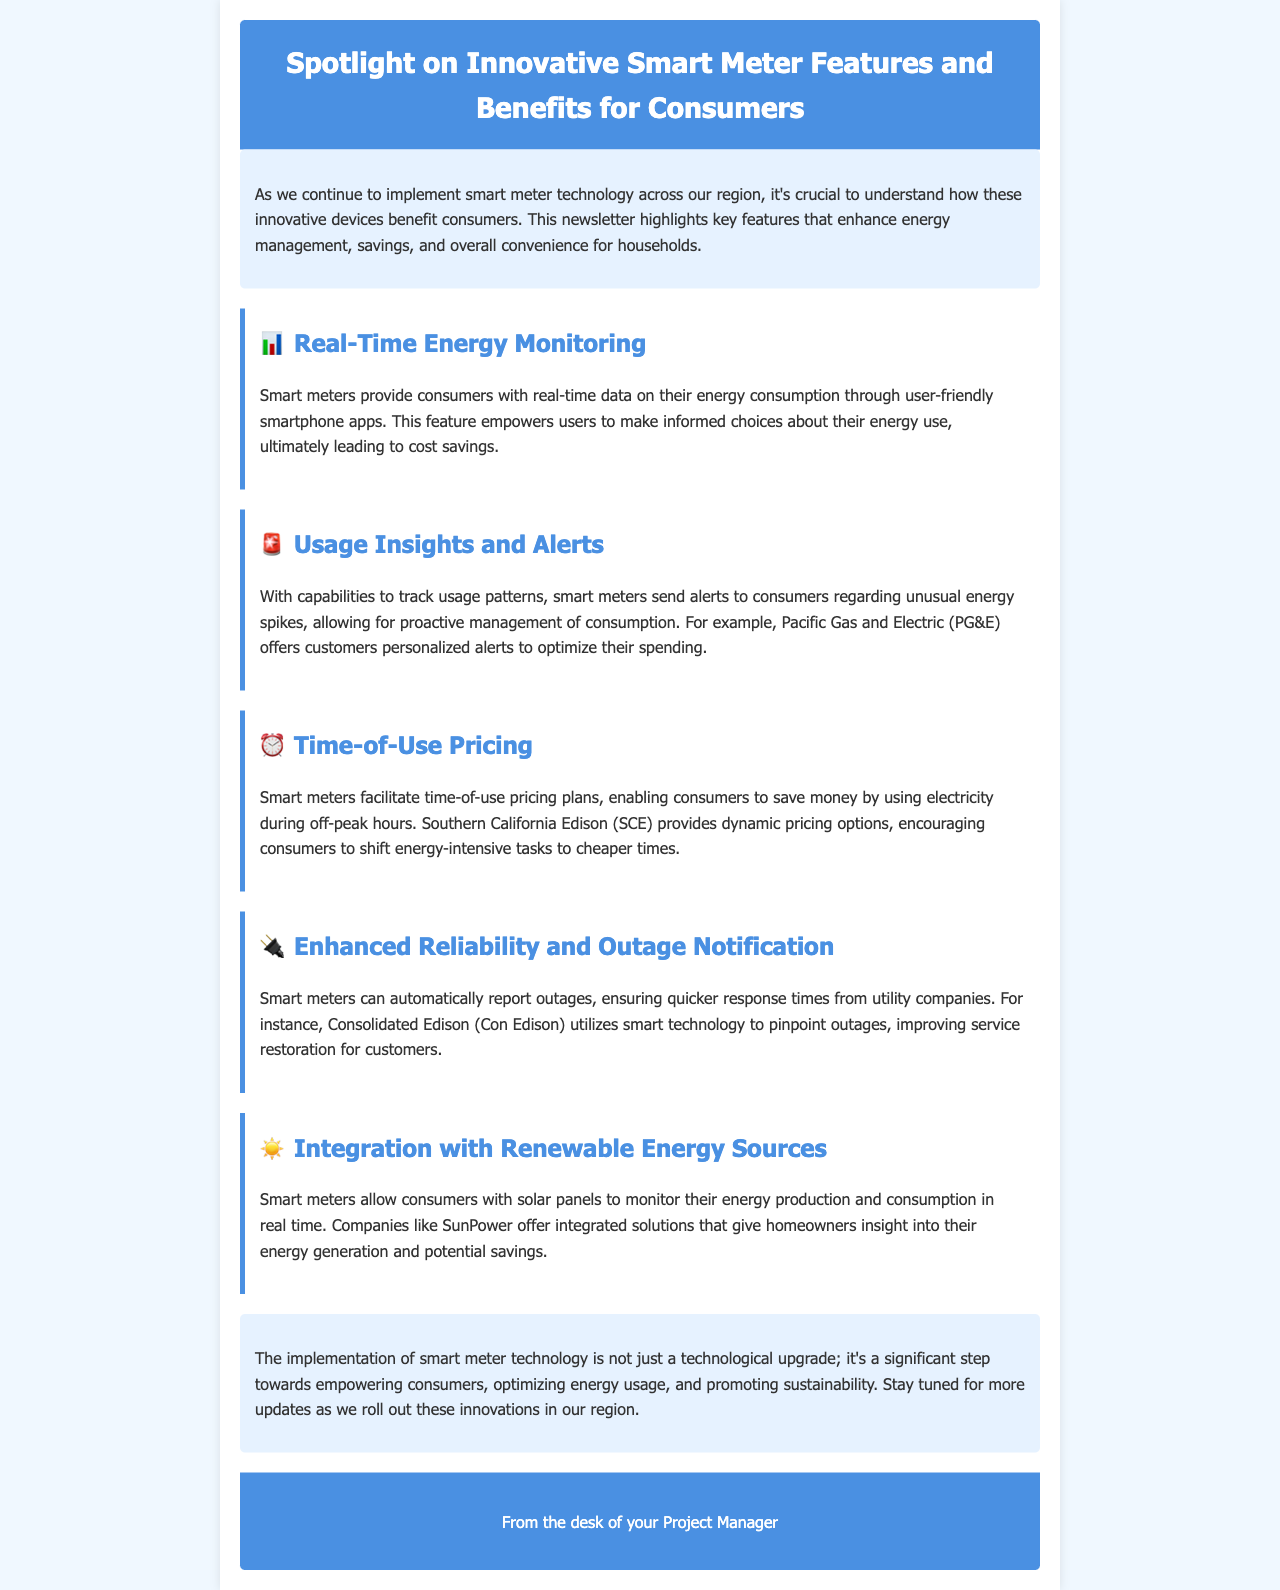What is the title of the newsletter? The title is the main heading of the document, which outlines the subject of the newsletter.
Answer: Spotlight on Innovative Smart Meter Features and Benefits for Consumers What is one feature of smart meters mentioned in the document? This feature corresponds to the highlighted sections under the features, showcasing various benefits consumers can enjoy.
Answer: Real-Time Energy Monitoring Which company provides personalized alerts for energy usage? The company mentioned specifically in relation to alerts for unusual energy usage is identified in the document.
Answer: Pacific Gas and Electric What pricing plan do smart meters facilitate? This involves a financial strategy highlighted in the newsletter that allows consumers to save money.
Answer: Time-of-Use Pricing What technology is used for enhanced outage notifications? This refers to the technology discussed in the context of reporting outages quickly and efficiently.
Answer: Smart meters What benefit does integration with renewable energy sources offer to consumers? The document states what consumers can monitor relating to their energy flow and production due to this feature.
Answer: Energy production and consumption What is the conclusion about the implementation of smart meters? This summarizes the overall significance and intention behind adopting smart meter technology as per the document.
Answer: Empowering consumers How does Southern California Edison encourage energy use? This refers to the approach mentioned in the newsletter that promotes savings for consumers by suggesting specific usage times.
Answer: Shift energy-intensive tasks to cheaper times 